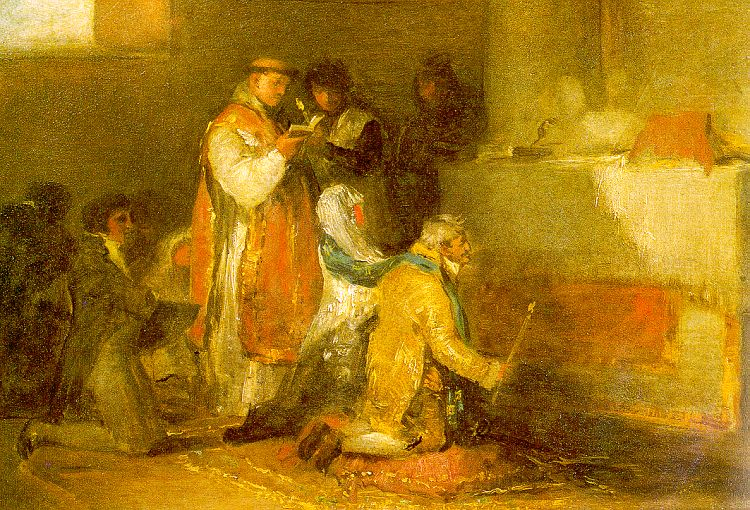What emotions do you perceive from the individuals in this painting? The individuals in the painting appear to be deeply engrossed in their activities, suggesting a range of emotions from concentration to contemplation. The person in the red robe seems focused and perhaps solemn as they read, indicating a possibly reflective or religious demeanor. The person kneeling in yellow appears devoted and introspective, suggesting a moment of prayer or meditation. The use of warm, muted colors and soft brushstrokes adds a layer of tranquility and serenity to the overall scene. 